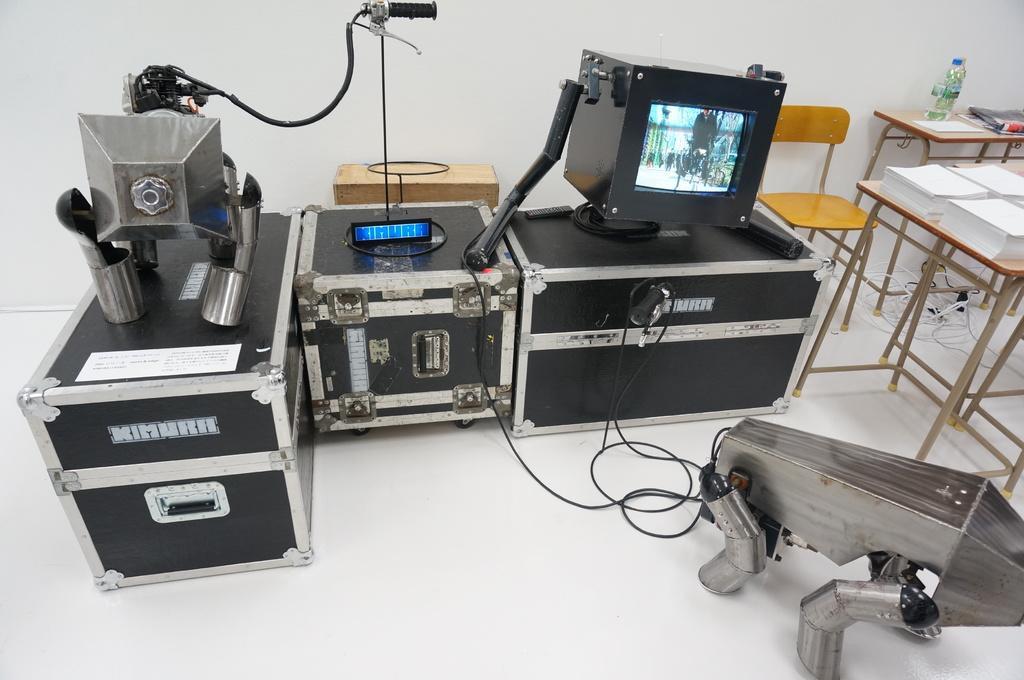Can you describe this image briefly? In this picture, there is a equipment and a monitor here. There are some chairs, table on which some papers were placed. In the background there is a wall. 